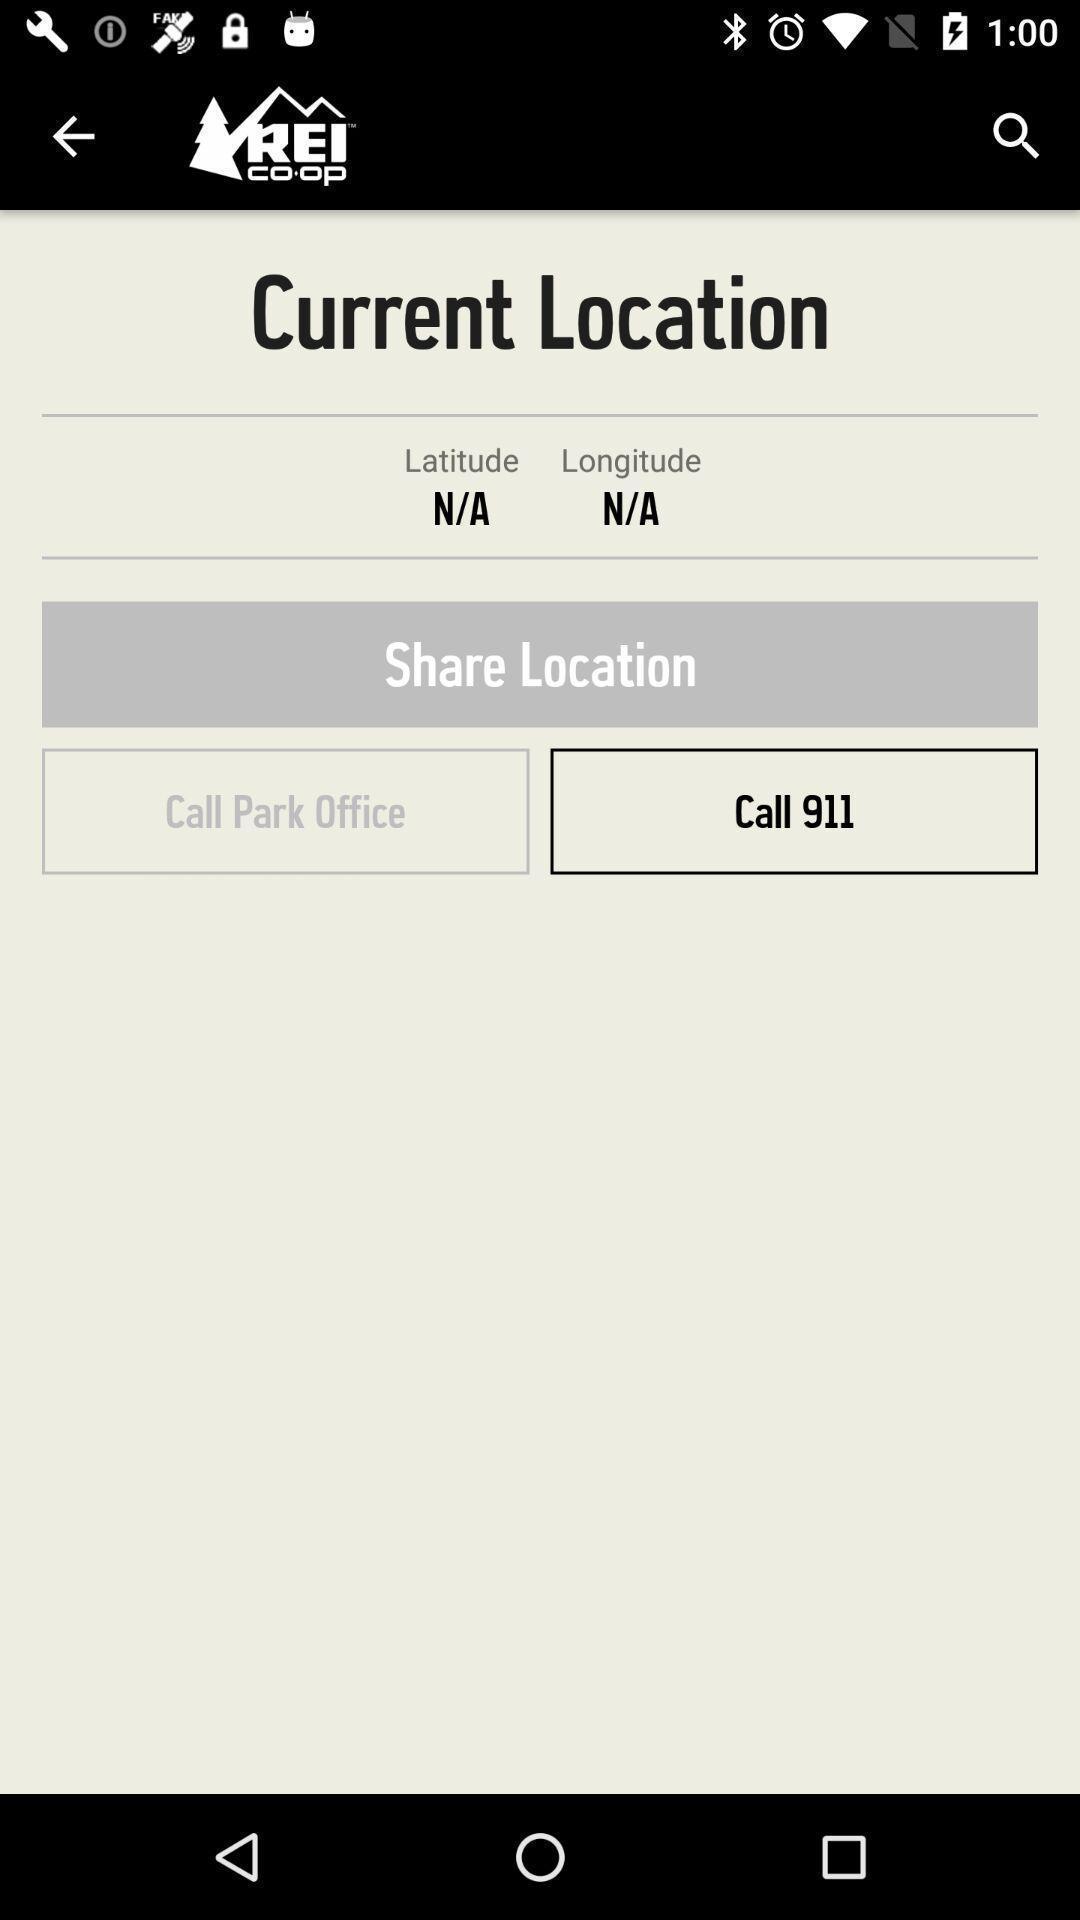Summarize the main components in this picture. Start page of a site seeing guiding app. 